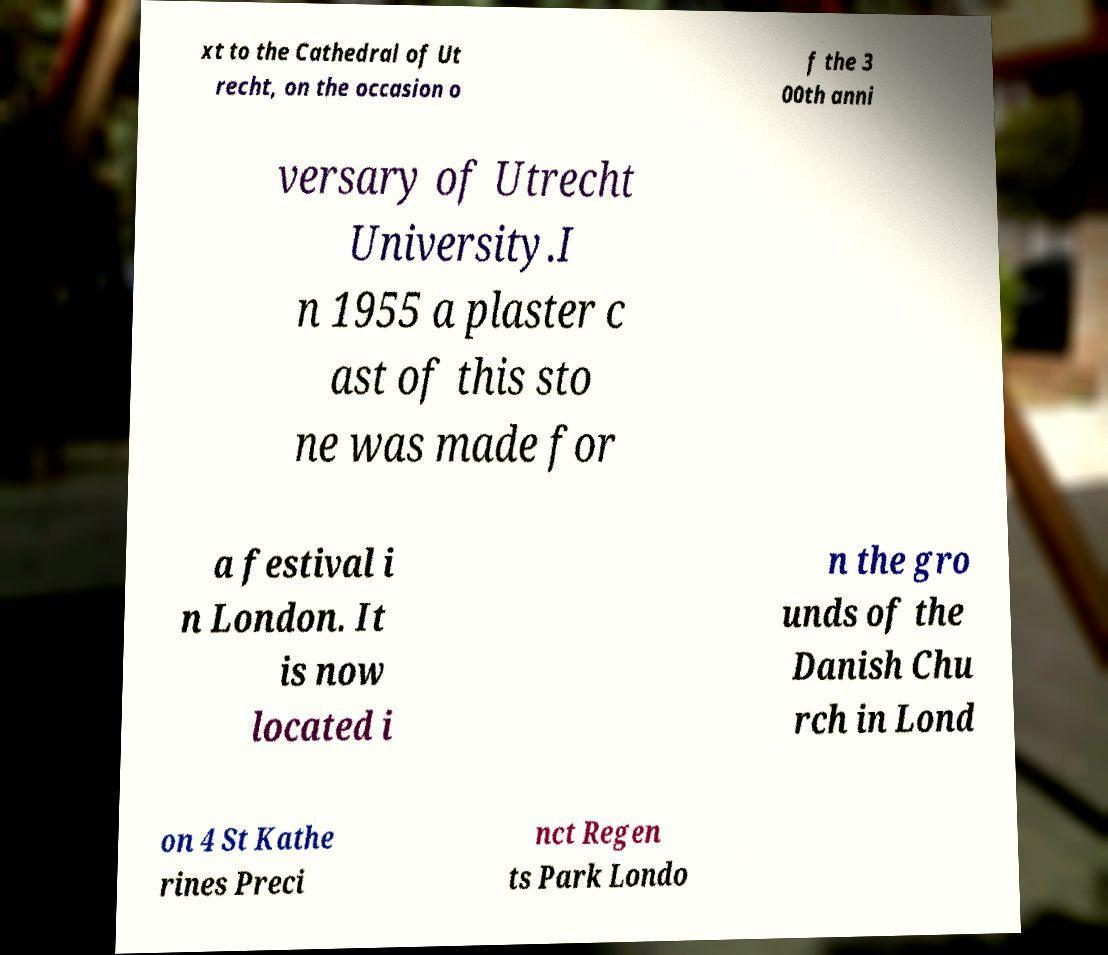Can you accurately transcribe the text from the provided image for me? xt to the Cathedral of Ut recht, on the occasion o f the 3 00th anni versary of Utrecht University.I n 1955 a plaster c ast of this sto ne was made for a festival i n London. It is now located i n the gro unds of the Danish Chu rch in Lond on 4 St Kathe rines Preci nct Regen ts Park Londo 